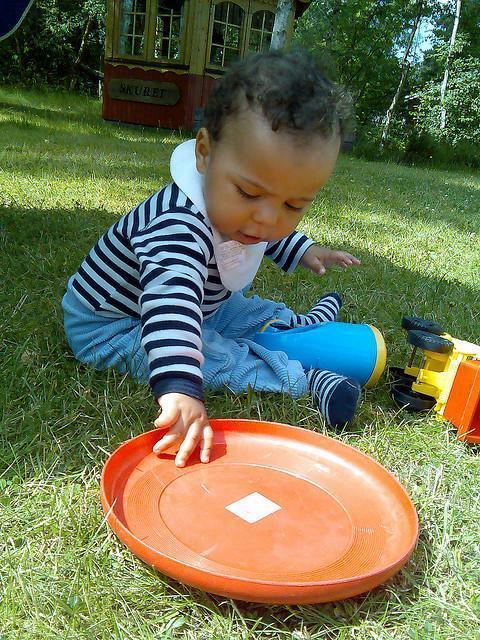How many kids are there?
Give a very brief answer. 1. How many suitcases are in this photo?
Give a very brief answer. 0. 